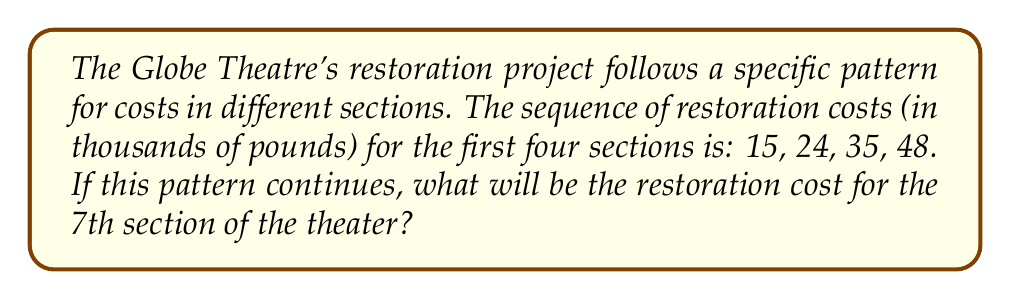Give your solution to this math problem. To solve this problem, let's follow these steps:

1) First, we need to identify the pattern in the given sequence:
   15, 24, 35, 48

2) Let's calculate the differences between consecutive terms:
   24 - 15 = 9
   35 - 24 = 11
   48 - 35 = 13

3) We can see that the difference is increasing by 2 each time:
   9, 11, 13 (each term is 2 more than the previous)

4) This suggests that the sequence follows a quadratic pattern.

5) The general form of a quadratic sequence is:
   $a_n = an^2 + bn + c$, where $n$ is the term number

6) We can set up a system of equations using the given terms:
   $15 = a(1)^2 + b(1) + c$
   $24 = a(2)^2 + b(2) + c$
   $35 = a(3)^2 + b(3) + c$

7) Solving this system (which is a bit complex to show here), we get:
   $a = 2$, $b = 1$, $c = 12$

8) So, our sequence formula is:
   $a_n = 2n^2 + n + 12$

9) For the 7th term, we substitute $n = 7$:
   $a_7 = 2(7)^2 + 7 + 12$
   $a_7 = 2(49) + 7 + 12$
   $a_7 = 98 + 7 + 12$
   $a_7 = 117$

Therefore, the restoration cost for the 7th section will be 117 thousand pounds.
Answer: £117,000 